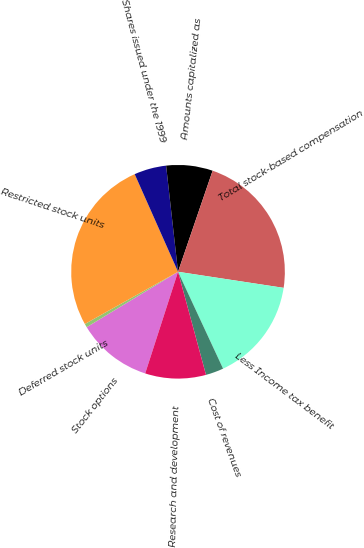<chart> <loc_0><loc_0><loc_500><loc_500><pie_chart><fcel>Stock options<fcel>Deferred stock units<fcel>Restricted stock units<fcel>Shares issued under the 1999<fcel>Amounts capitalized as<fcel>Total stock-based compensation<fcel>Less Income tax benefit<fcel>Cost of revenues<fcel>Research and development<nl><fcel>11.35%<fcel>0.55%<fcel>26.48%<fcel>4.87%<fcel>7.03%<fcel>22.16%<fcel>15.67%<fcel>2.71%<fcel>9.19%<nl></chart> 